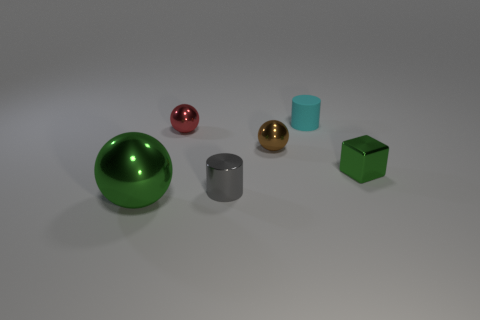Are there any other things that are the same size as the green ball?
Make the answer very short. No. There is a tiny thing that is behind the tiny red sphere; is it the same shape as the big green object?
Ensure brevity in your answer.  No. There is a green object that is right of the metallic cylinder; what material is it?
Your answer should be very brief. Metal. What number of matte things are yellow cubes or gray things?
Your answer should be compact. 0. Is there a gray metal cylinder of the same size as the green metal block?
Your response must be concise. Yes. Is the number of cyan matte objects that are behind the gray metal cylinder greater than the number of large blue metallic cylinders?
Your answer should be very brief. Yes. What number of small objects are balls or blue shiny cylinders?
Provide a short and direct response. 2. What number of other big green shiny things have the same shape as the large green shiny object?
Give a very brief answer. 0. There is a small cylinder behind the small cylinder left of the tiny brown thing; what is it made of?
Offer a very short reply. Rubber. What size is the metallic thing that is right of the cyan thing?
Keep it short and to the point. Small. 